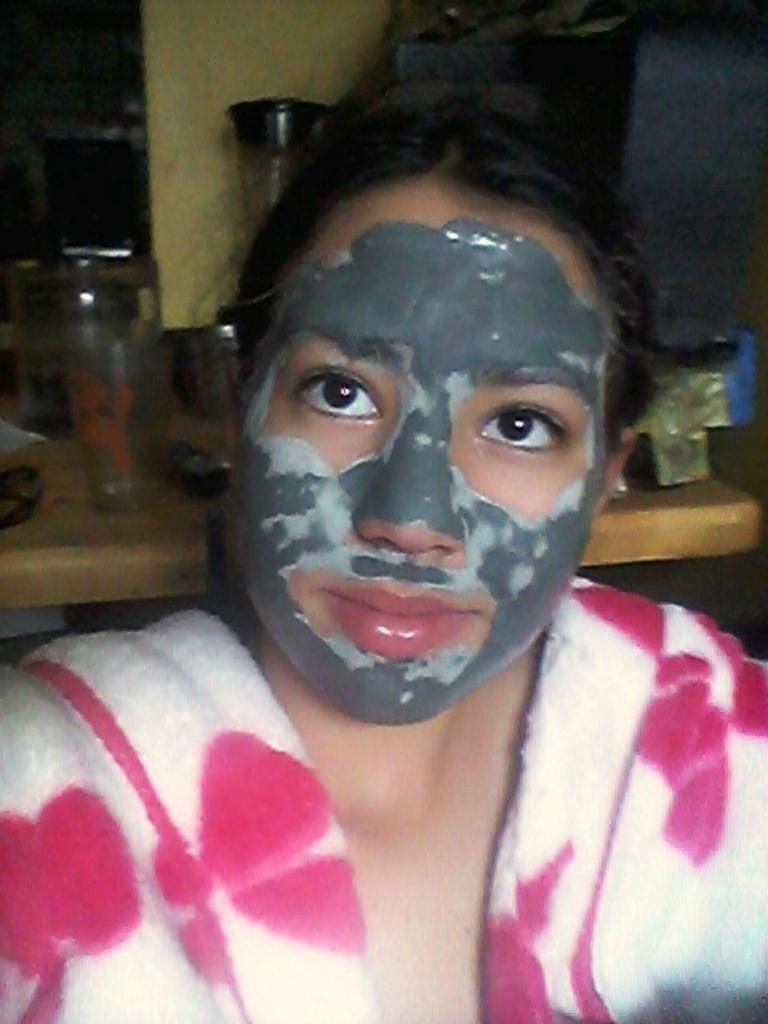Who is present in the image? There is a lady in the image. What is the lady wearing on her face? The lady is wearing a face mask. What can be seen in the background of the image? There are objects on a table in the background of the image. What type of degree does the lady hold in the image? There is no indication in the image of the lady holding a degree. Can you tell me how many rifles are visible in the image? There are no rifles present in the image. 